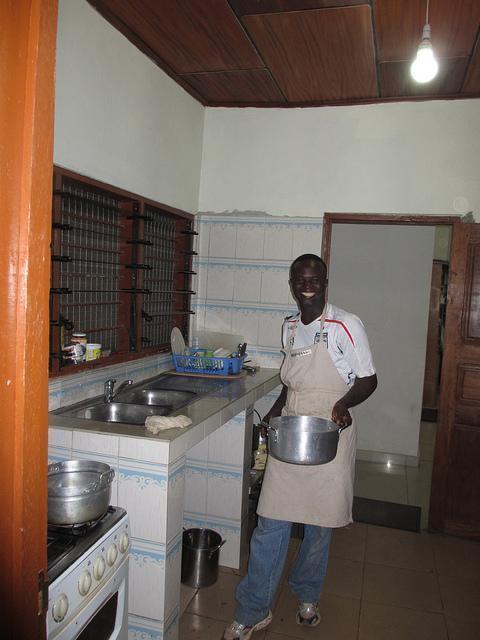This man is in a similar profession to what character?
Answer the question by selecting the correct answer among the 4 following choices and explain your choice with a short sentence. The answer should be formatted with the following format: `Answer: choice
Rationale: rationale.`
Options: Homer simpson, pikachu, chef boyardee, garfield. Answer: chef boyardee.
Rationale: The man is in the kitchen and wearing an apron holding cooking tools and would therefore likely be a chef. chef boyardee is a character that is also a chef. 